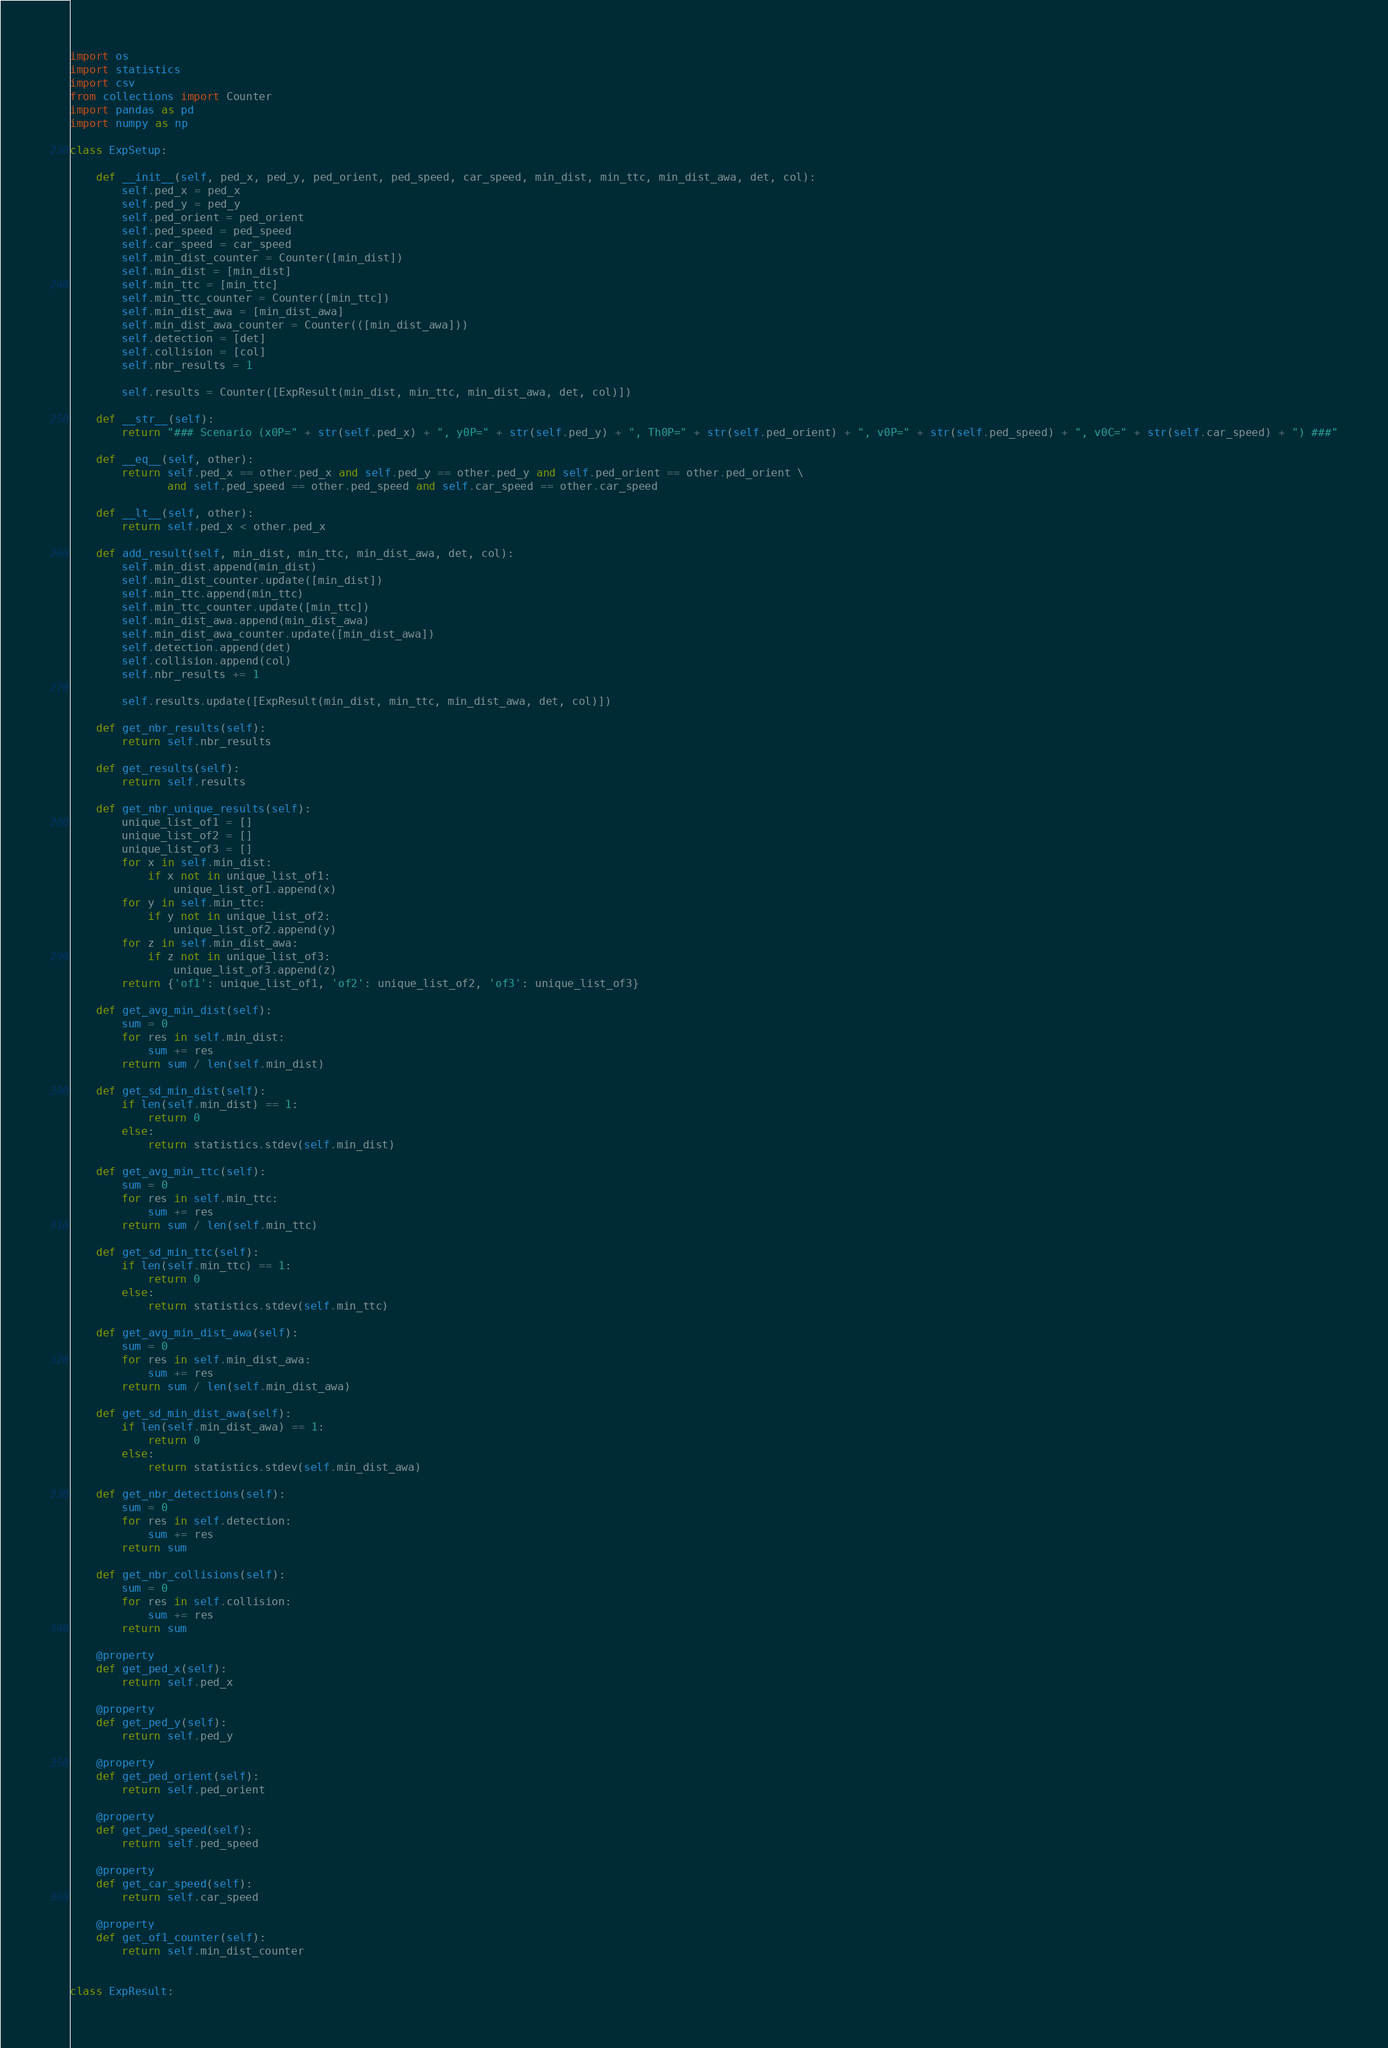Convert code to text. <code><loc_0><loc_0><loc_500><loc_500><_Python_>import os
import statistics
import csv
from collections import Counter
import pandas as pd
import numpy as np

class ExpSetup:

    def __init__(self, ped_x, ped_y, ped_orient, ped_speed, car_speed, min_dist, min_ttc, min_dist_awa, det, col):
        self.ped_x = ped_x
        self.ped_y = ped_y
        self.ped_orient = ped_orient
        self.ped_speed = ped_speed
        self.car_speed = car_speed
        self.min_dist_counter = Counter([min_dist])
        self.min_dist = [min_dist]
        self.min_ttc = [min_ttc]
        self.min_ttc_counter = Counter([min_ttc])
        self.min_dist_awa = [min_dist_awa]
        self.min_dist_awa_counter = Counter(([min_dist_awa]))
        self.detection = [det]
        self.collision = [col]
        self.nbr_results = 1

        self.results = Counter([ExpResult(min_dist, min_ttc, min_dist_awa, det, col)])

    def __str__(self):
        return "### Scenario (x0P=" + str(self.ped_x) + ", y0P=" + str(self.ped_y) + ", Th0P=" + str(self.ped_orient) + ", v0P=" + str(self.ped_speed) + ", v0C=" + str(self.car_speed) + ") ###"

    def __eq__(self, other):
        return self.ped_x == other.ped_x and self.ped_y == other.ped_y and self.ped_orient == other.ped_orient \
               and self.ped_speed == other.ped_speed and self.car_speed == other.car_speed

    def __lt__(self, other):
        return self.ped_x < other.ped_x

    def add_result(self, min_dist, min_ttc, min_dist_awa, det, col):
        self.min_dist.append(min_dist)
        self.min_dist_counter.update([min_dist])
        self.min_ttc.append(min_ttc)
        self.min_ttc_counter.update([min_ttc])
        self.min_dist_awa.append(min_dist_awa)
        self.min_dist_awa_counter.update([min_dist_awa])
        self.detection.append(det)
        self.collision.append(col)
        self.nbr_results += 1

        self.results.update([ExpResult(min_dist, min_ttc, min_dist_awa, det, col)])

    def get_nbr_results(self):
        return self.nbr_results

    def get_results(self):
        return self.results

    def get_nbr_unique_results(self):
        unique_list_of1 = []
        unique_list_of2 = []
        unique_list_of3 = []
        for x in self.min_dist:
            if x not in unique_list_of1:
                unique_list_of1.append(x)
        for y in self.min_ttc:
            if y not in unique_list_of2:
                unique_list_of2.append(y)
        for z in self.min_dist_awa:
            if z not in unique_list_of3:
                unique_list_of3.append(z)
        return {'of1': unique_list_of1, 'of2': unique_list_of2, 'of3': unique_list_of3}

    def get_avg_min_dist(self):
        sum = 0
        for res in self.min_dist:
            sum += res
        return sum / len(self.min_dist)

    def get_sd_min_dist(self):
        if len(self.min_dist) == 1:
            return 0
        else:
            return statistics.stdev(self.min_dist)

    def get_avg_min_ttc(self):
        sum = 0
        for res in self.min_ttc:
            sum += res
        return sum / len(self.min_ttc)

    def get_sd_min_ttc(self):
        if len(self.min_ttc) == 1:
            return 0
        else:
            return statistics.stdev(self.min_ttc)

    def get_avg_min_dist_awa(self):
        sum = 0
        for res in self.min_dist_awa:
            sum += res
        return sum / len(self.min_dist_awa)

    def get_sd_min_dist_awa(self):
        if len(self.min_dist_awa) == 1:
            return 0
        else:
            return statistics.stdev(self.min_dist_awa)

    def get_nbr_detections(self):
        sum = 0
        for res in self.detection:
            sum += res
        return sum

    def get_nbr_collisions(self):
        sum = 0
        for res in self.collision:
            sum += res
        return sum

    @property
    def get_ped_x(self):
        return self.ped_x

    @property
    def get_ped_y(self):
        return self.ped_y

    @property
    def get_ped_orient(self):
        return self.ped_orient

    @property
    def get_ped_speed(self):
        return self.ped_speed

    @property
    def get_car_speed(self):
        return self.car_speed

    @property
    def get_of1_counter(self):
        return self.min_dist_counter


class ExpResult:
</code> 